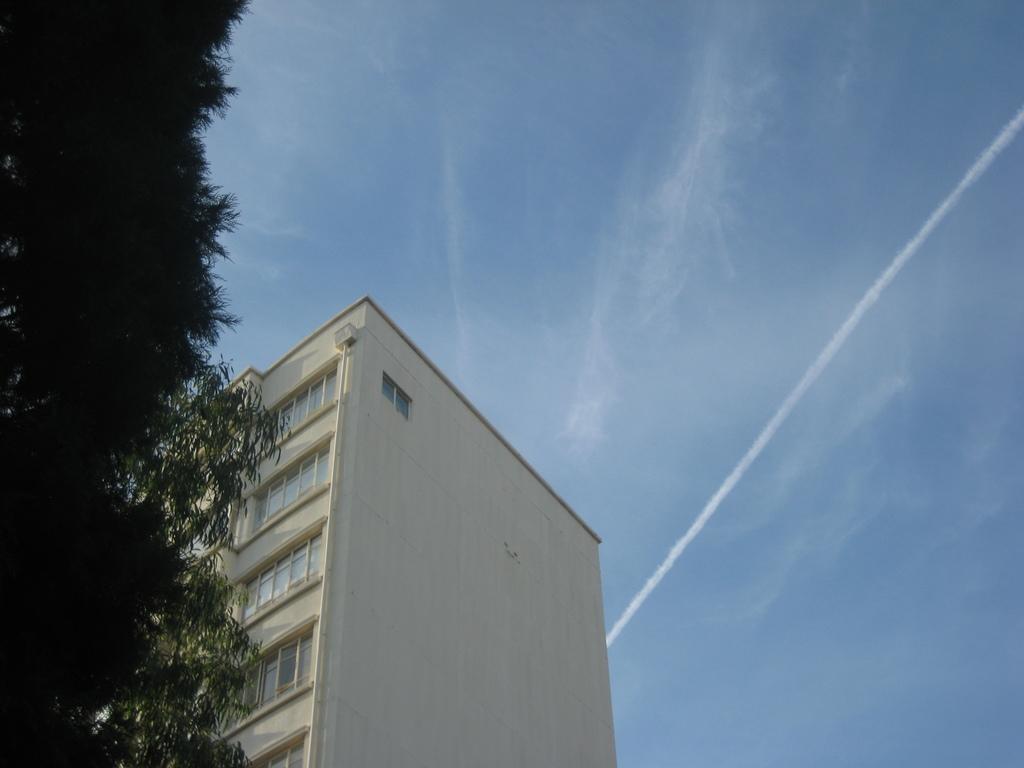Can you describe this image briefly? In this image, we can see a building, walls, windows and pipe. On the left side of the image, we can see the tree. Background there is a sky. 